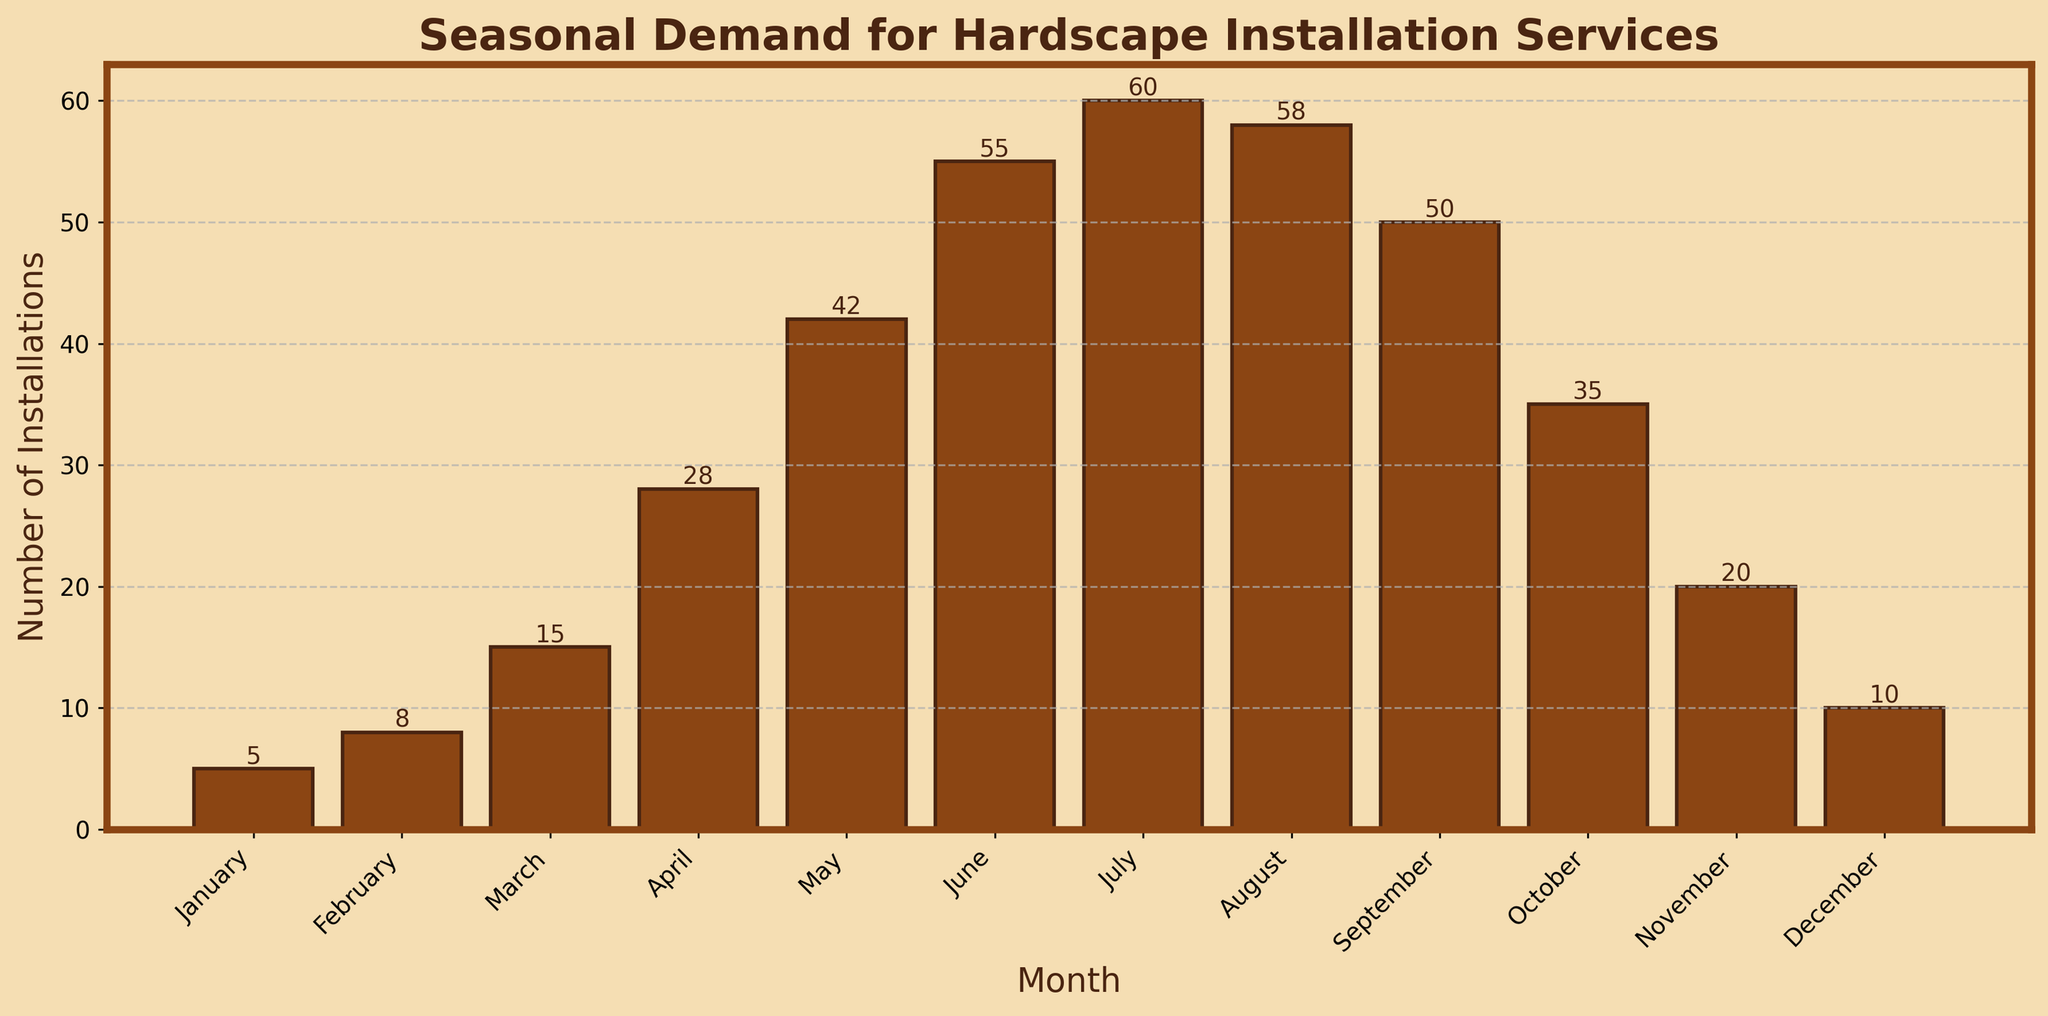Which month has the highest number of installations? By looking at the height of the bars, July has the tallest bar, indicating the highest number of installations.
Answer: July How many more installations are there in May compared to January? Refer to the bar heights for May and January: May has 42 installations and January has 5. Subtract January from May: 42 - 5 = 37.
Answer: 37 What is the total number of installations from June to August? Sum the installations for June (55), July (60), and August (58): 55 + 60 + 58 = 173.
Answer: 173 Which month shows the least number of installations? The shortest bar represents January with the least number of installations, which is 5.
Answer: January What is the average number of installations per month? Sum the installations for all months: 5 + 8 + 15 + 28 + 42 + 55 + 60 + 58 + 50 + 35 + 20 + 10 = 386. Then divide by the number of months (12): 386 / 12 = 32.17.
Answer: 32.17 Is the number of installations in March greater or less than those in November? Compare the heights of the bars for March (15) and November (20). March has fewer installations than November (15 < 20).
Answer: less During which quarter (3-month period) of the year is the demand for installations the highest? Sum the installations for each quarter: 
   - Q1 (Jan, Feb, Mar): 5 + 8 + 15 = 28,
   - Q2 (Apr, May, Jun): 28 + 42 + 55 = 125,
   - Q3 (Jul, Aug, Sep): 60 + 58 + 50 = 168,
   - Q4 (Oct, Nov, Dec): 35 + 20 + 10 = 65.
   The third quarter has the highest number of installations (168).
Answer: Q3 How do the number of installations in September compare to those in October and November combined? Compare the installations in September (50) with the sum of installations in October (35) and November (20): 35 + 20 = 55. September has fewer installations than October and November combined (50 < 55).
Answer: fewer What is the difference between the highest and lowest number of installations observed in a month? Identify the highest and lowest installations: July (60) and January (5). Subtract the lowest from the highest: 60 - 5 = 55.
Answer: 55 